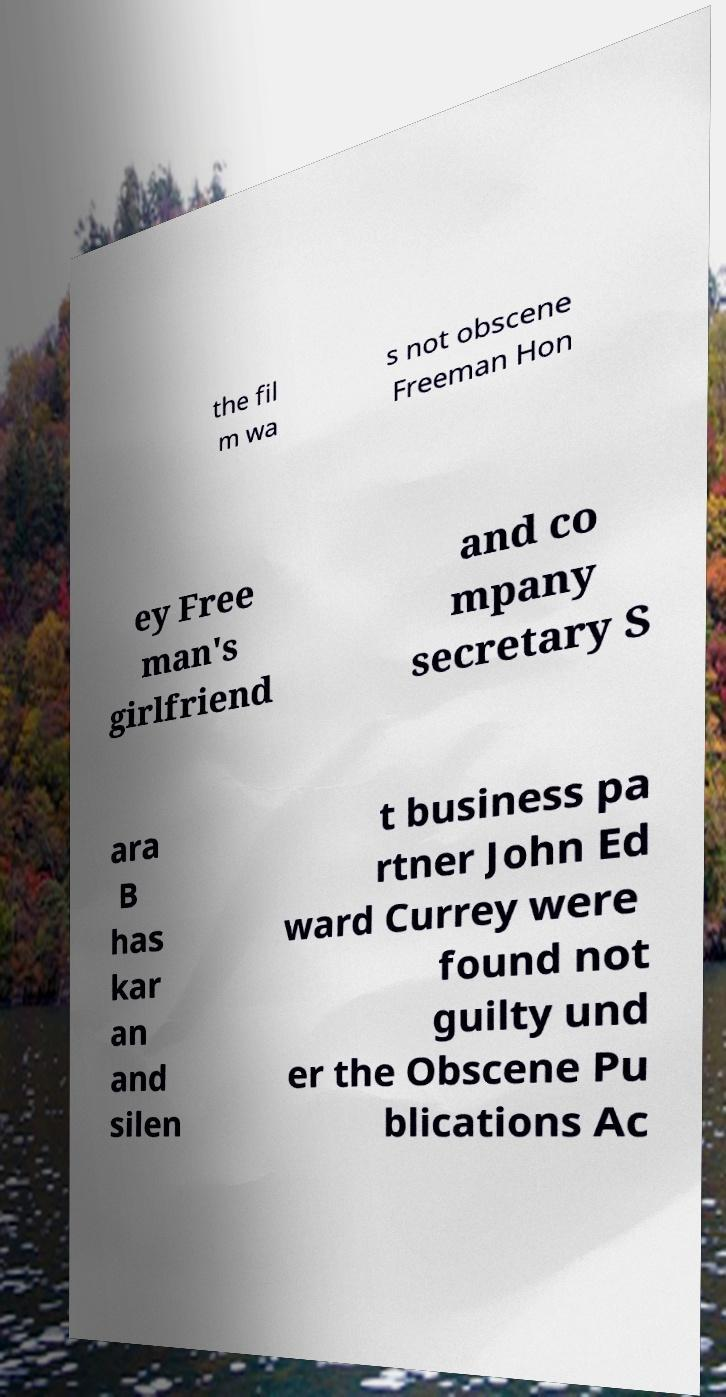Could you extract and type out the text from this image? the fil m wa s not obscene Freeman Hon ey Free man's girlfriend and co mpany secretary S ara B has kar an and silen t business pa rtner John Ed ward Currey were found not guilty und er the Obscene Pu blications Ac 